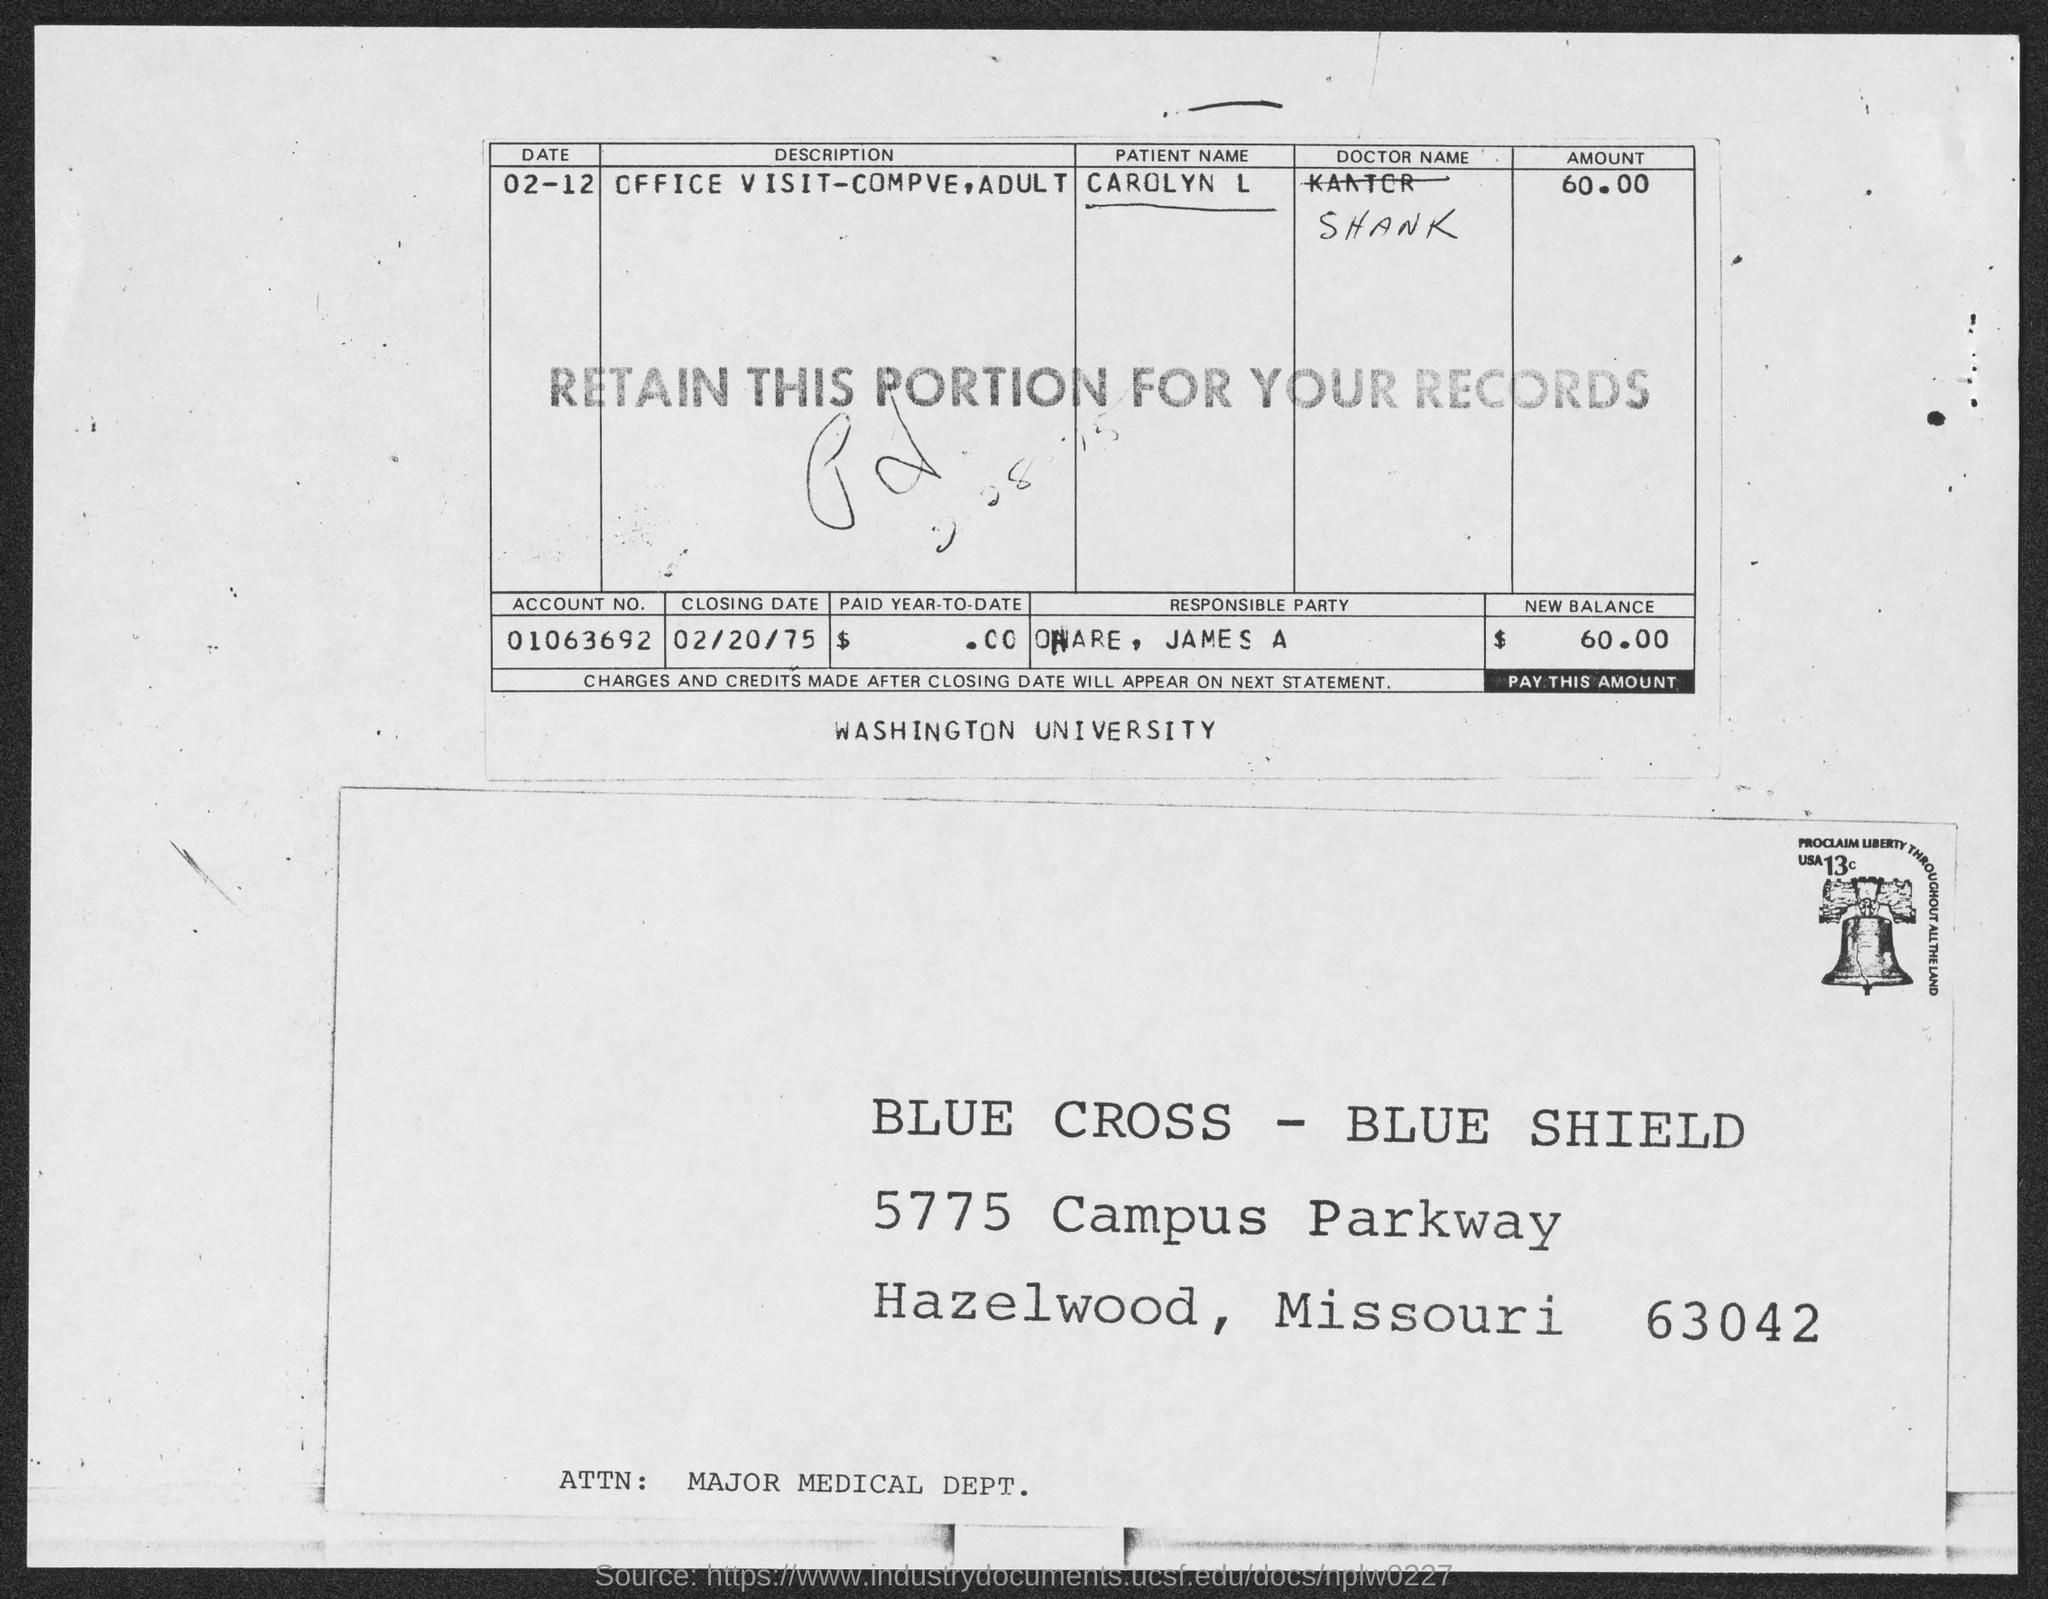What is the zip code mentioned in the address?
Offer a terse response. 63042. What is the name of the university mentioned in the middle of the document?
Provide a succinct answer. Washington university. What is the account no. mentioned in the table?
Your answer should be compact. 01063692. What is the name of the patient?
Keep it short and to the point. Carolyn l. What is the "amount" mentioned in the table?
Make the answer very short. 60.00. What is the "new balance"  to be paid?
Your answer should be compact. $     60.00. What is the closing date mentioned in the table?
Keep it short and to the point. 02/20/75. 